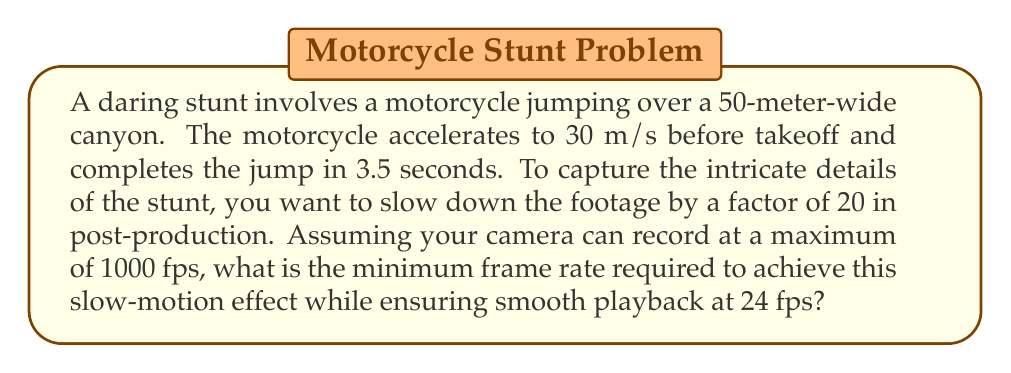Teach me how to tackle this problem. Let's approach this step-by-step:

1) First, we need to understand the relationship between real-time and slow-motion playback:
   - Slow-motion factor = 20
   - Playback frame rate = 24 fps

2) To calculate the required frame rate, we use the formula:
   $$ \text{Required Frame Rate} = \text{Slow-motion factor} \times \text{Playback frame rate} $$

3) Plugging in our values:
   $$ \text{Required Frame Rate} = 20 \times 24 \text{ fps} = 480 \text{ fps} $$

4) Now, let's verify if this frame rate is sufficient to capture the stunt smoothly:
   - Stunt duration = 3.5 seconds
   - Total frames captured = $480 \text{ fps} \times 3.5 \text{ s} = 1680 \text{ frames}$

5) In slow-motion playback:
   - Playback duration = $3.5 \text{ s} \times 20 = 70 \text{ seconds}$
   - Frames per second during playback = $1680 \text{ frames} \div 70 \text{ s} = 24 \text{ fps}$

6) This matches our target playback frame rate, confirming that 480 fps is sufficient.

7) Finally, we check if this is within the camera's capabilities:
   - Maximum camera frame rate = 1000 fps
   - Required frame rate (480 fps) < Maximum camera frame rate (1000 fps)

Therefore, 480 fps is the minimum frame rate required to achieve the desired slow-motion effect while ensuring smooth playback.
Answer: 480 fps 